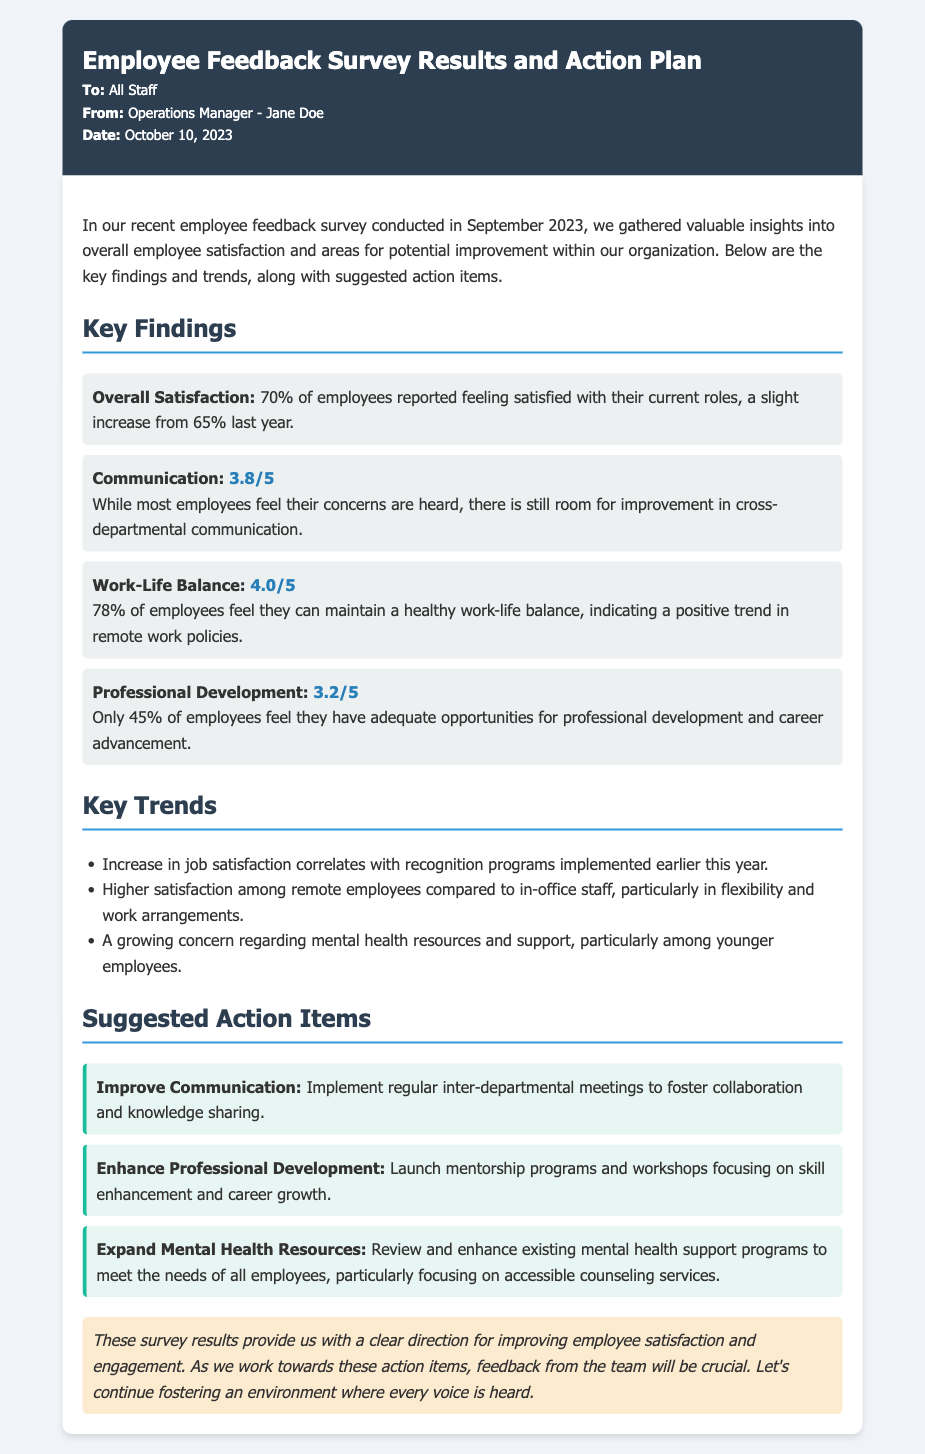What was the overall employee satisfaction percentage this year? The document states that 70% of employees reported feeling satisfied with their current roles.
Answer: 70% What is the score for Communication? The document indicates a score of 3.8 out of 5 for Communication.
Answer: 3.8/5 What percentage of employees feel they can maintain a healthy work-life balance? The document highlights that 78% of employees feel they can maintain a healthy work-life balance.
Answer: 78% Which area had the lowest satisfaction score? The Professional Development section received a score of 3.2 out of 5, indicating lower satisfaction.
Answer: Professional Development What is suggested to improve inter-departmental communication? The action item suggests implementing regular inter-departmental meetings to foster collaboration.
Answer: Implement regular inter-departmental meetings What trend was observed among remote employees compared to in-office staff? The document notes higher satisfaction among remote employees in terms of flexibility and work arrangements.
Answer: Higher satisfaction in flexibility Which group expressed a growing concern about mental health resources? The document specifically mentions younger employees as having growing concerns regarding mental health resources.
Answer: Younger employees What type of memo is this document classified as? This document is classified as a memo detailing employee feedback survey results and action plans.
Answer: Memo 